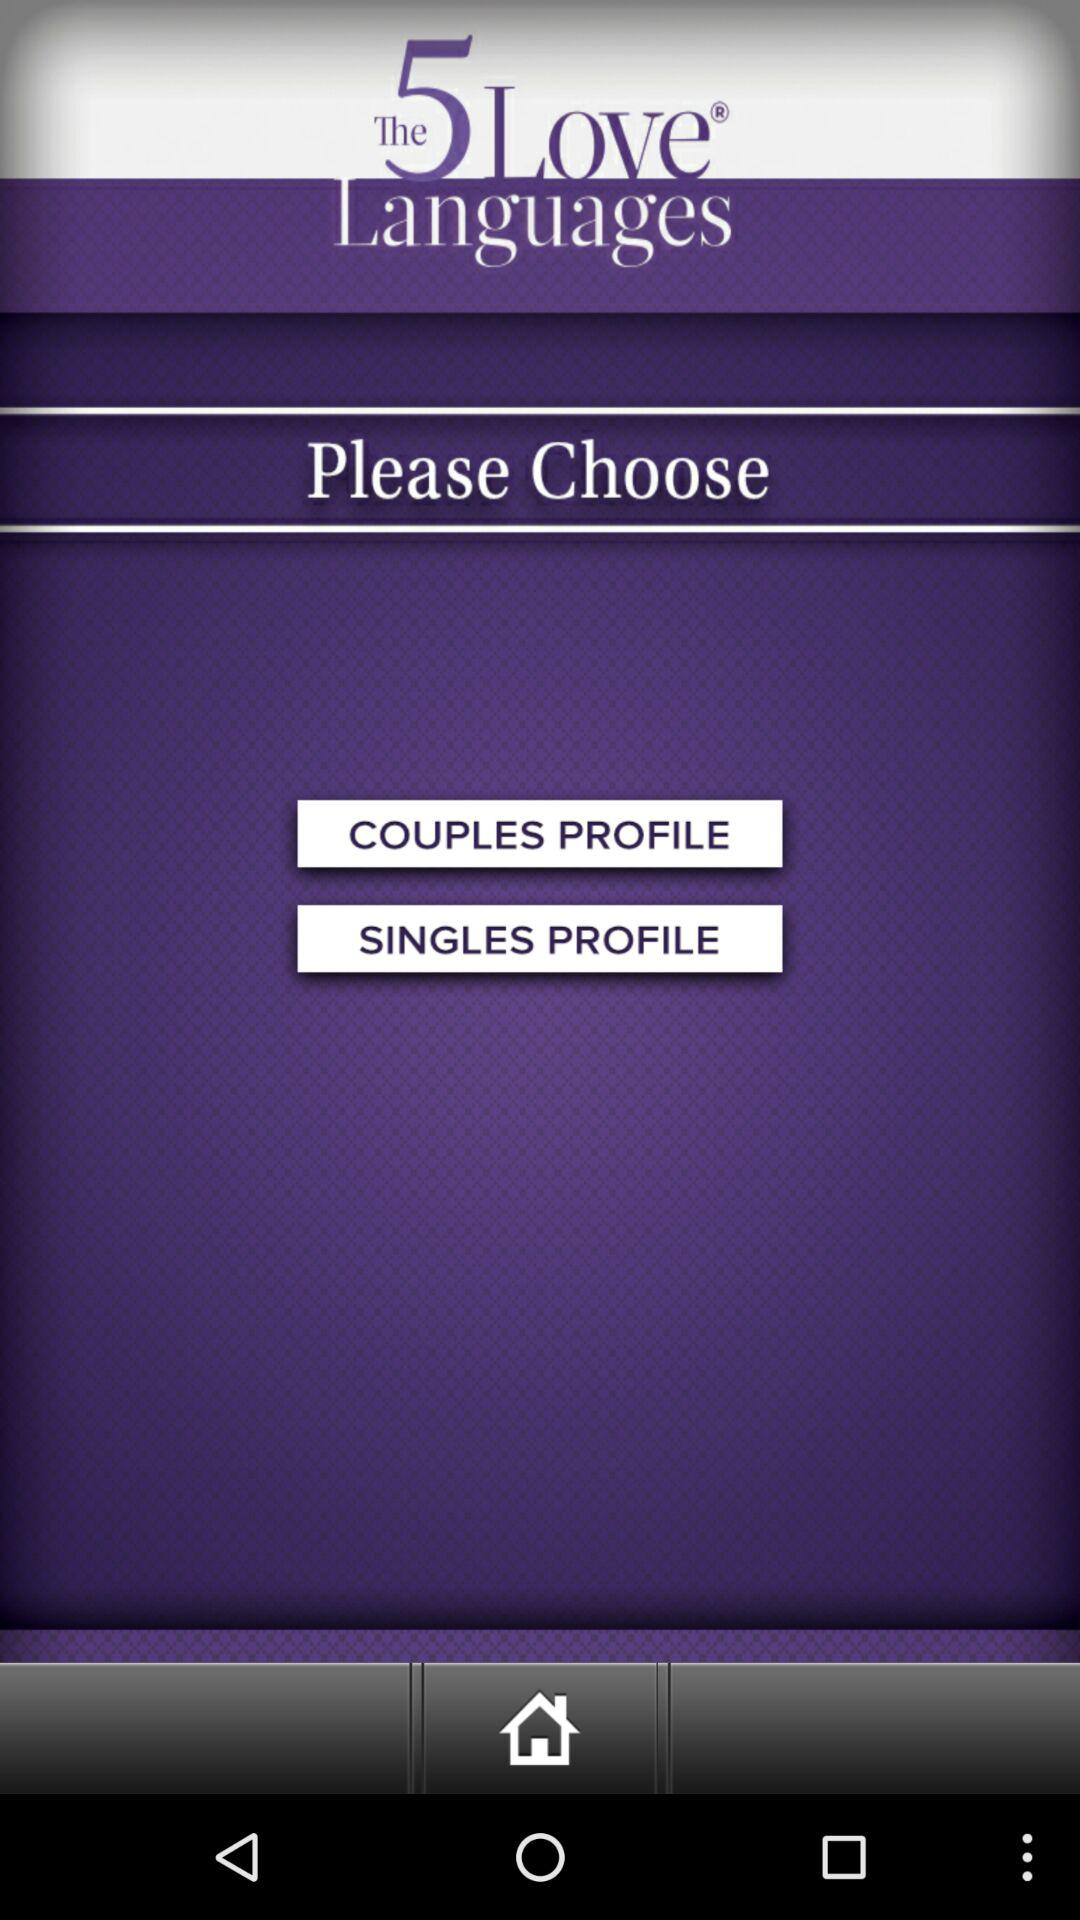Which options are given for choosing? The options given for choosing are "COUPLES PROFILE" and "SINGLES PROFILE". 